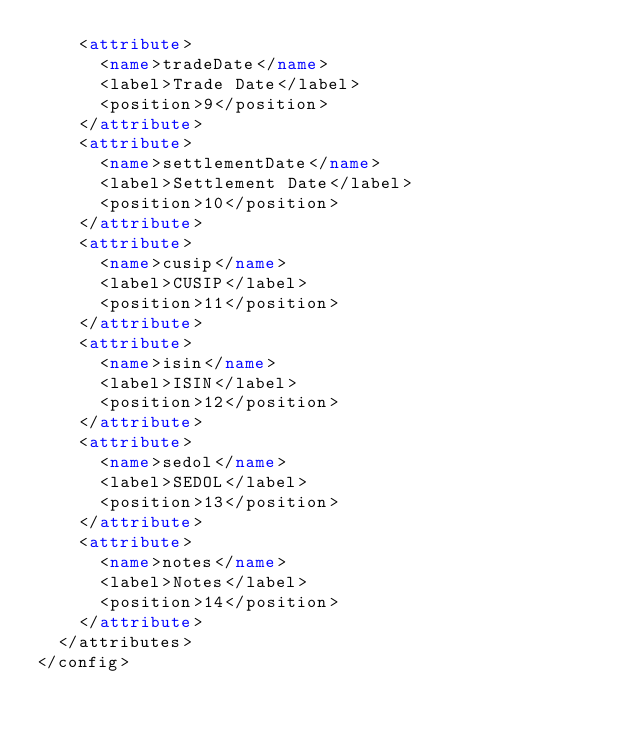<code> <loc_0><loc_0><loc_500><loc_500><_XML_>    <attribute>
      <name>tradeDate</name>
      <label>Trade Date</label>
      <position>9</position>
    </attribute>
    <attribute>
      <name>settlementDate</name>
      <label>Settlement Date</label>
      <position>10</position>
    </attribute>
    <attribute>
      <name>cusip</name>
      <label>CUSIP</label>
      <position>11</position>
    </attribute>
    <attribute>
      <name>isin</name>
      <label>ISIN</label>
      <position>12</position>
    </attribute>
    <attribute>
      <name>sedol</name>
      <label>SEDOL</label>
      <position>13</position>
    </attribute>
    <attribute>
      <name>notes</name>
      <label>Notes</label>
      <position>14</position>
    </attribute>
  </attributes>
</config>
</code> 